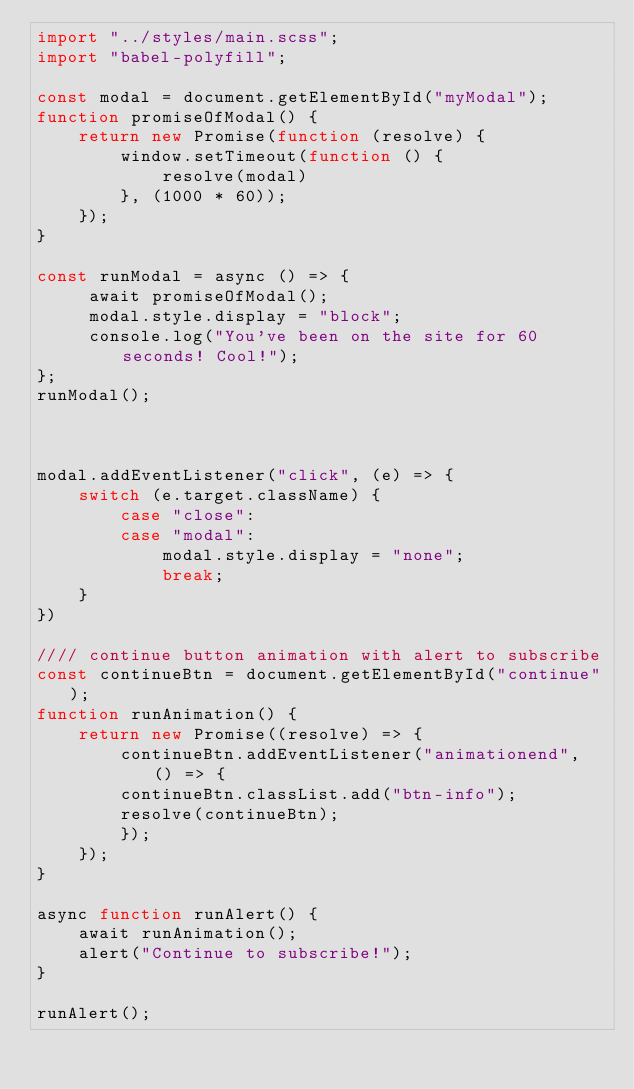<code> <loc_0><loc_0><loc_500><loc_500><_JavaScript_>import "../styles/main.scss";
import "babel-polyfill";

const modal = document.getElementById("myModal");
function promiseOfModal() {
    return new Promise(function (resolve) {
        window.setTimeout(function () {
            resolve(modal)
        }, (1000 * 60));
    });
} 

const runModal = async () => {
     await promiseOfModal();     
     modal.style.display = "block";
     console.log("You've been on the site for 60 seconds! Cool!");
};
runModal(); 



modal.addEventListener("click", (e) => {
    switch (e.target.className) {
        case "close":
        case "modal":
            modal.style.display = "none";
            break;
    }
})

//// continue button animation with alert to subscribe
const continueBtn = document.getElementById("continue");
function runAnimation() {
    return new Promise((resolve) => {
        continueBtn.addEventListener("animationend", () => {
        continueBtn.classList.add("btn-info");
        resolve(continueBtn);
        });
    });
}

async function runAlert() {
    await runAnimation();
    alert("Continue to subscribe!");
}

runAlert();

</code> 